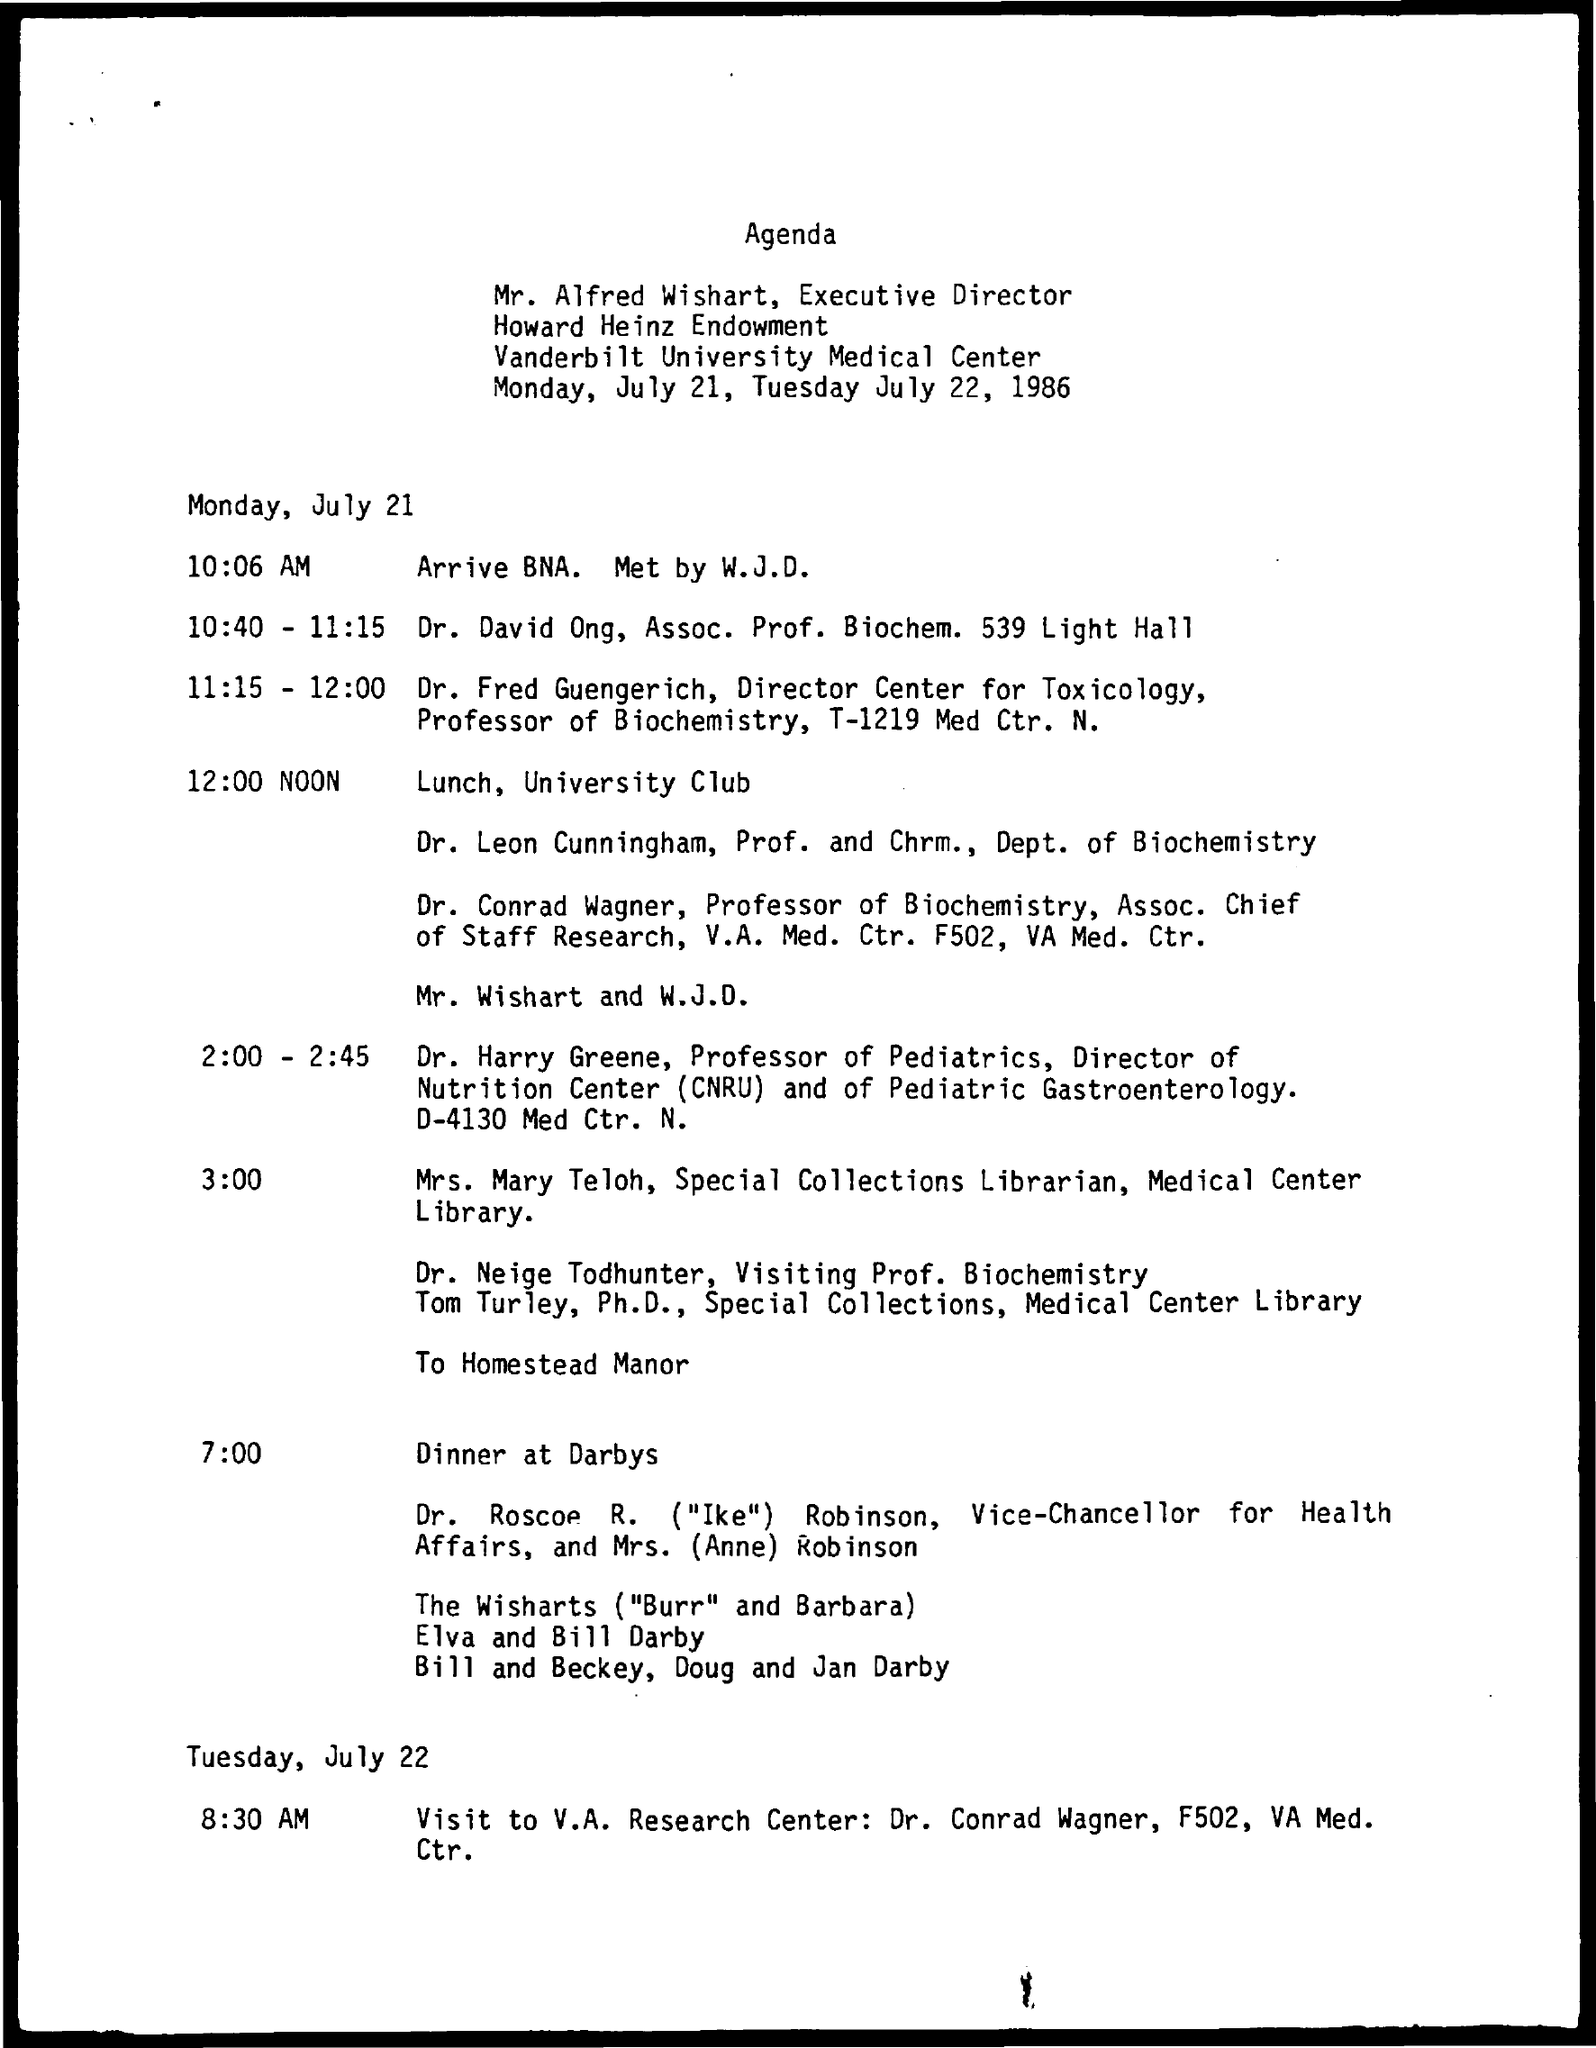What is the designation of Mr. Alfred Wishart?
Make the answer very short. Executive Director. Who is the Special Collections Librarian, Medical Center Library?
Make the answer very short. Mrs. Mary Teloh. What time is the lunch organized on Monday, July 21?
Your answer should be very brief. 12:00 NOON. 